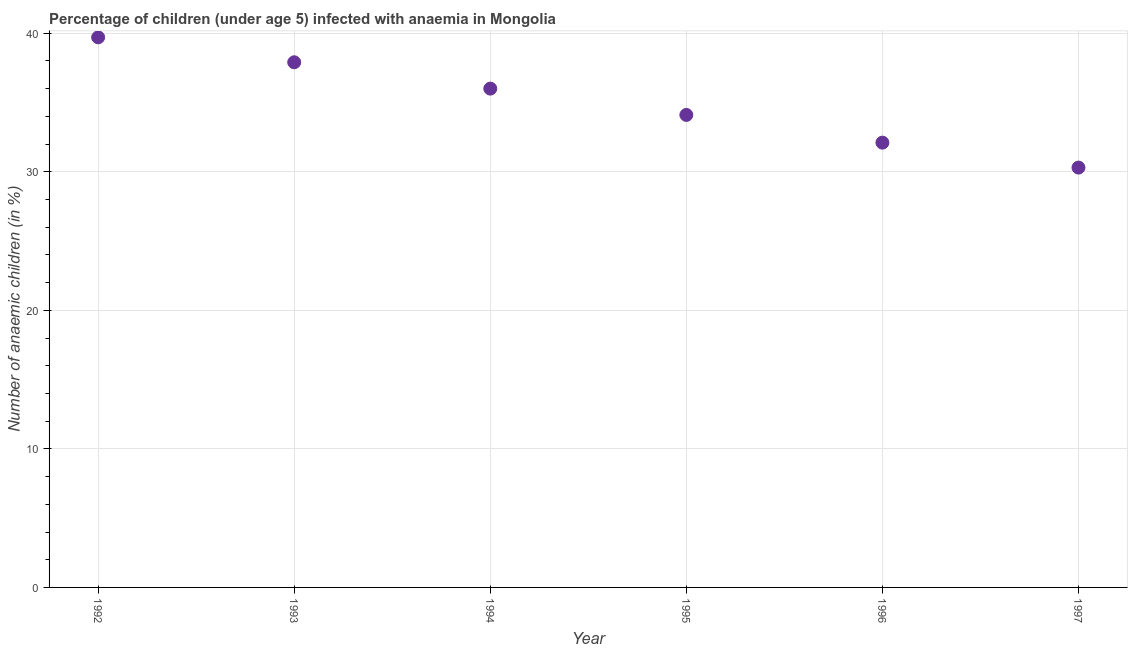What is the number of anaemic children in 1995?
Make the answer very short. 34.1. Across all years, what is the maximum number of anaemic children?
Provide a short and direct response. 39.7. Across all years, what is the minimum number of anaemic children?
Keep it short and to the point. 30.3. In which year was the number of anaemic children minimum?
Make the answer very short. 1997. What is the sum of the number of anaemic children?
Offer a very short reply. 210.1. What is the difference between the number of anaemic children in 1994 and 1997?
Provide a short and direct response. 5.7. What is the average number of anaemic children per year?
Your answer should be compact. 35.02. What is the median number of anaemic children?
Ensure brevity in your answer.  35.05. Do a majority of the years between 1997 and 1993 (inclusive) have number of anaemic children greater than 2 %?
Offer a very short reply. Yes. What is the ratio of the number of anaemic children in 1993 to that in 1995?
Make the answer very short. 1.11. What is the difference between the highest and the second highest number of anaemic children?
Provide a succinct answer. 1.8. What is the difference between the highest and the lowest number of anaemic children?
Give a very brief answer. 9.4. In how many years, is the number of anaemic children greater than the average number of anaemic children taken over all years?
Provide a succinct answer. 3. Does the number of anaemic children monotonically increase over the years?
Your answer should be very brief. No. How many dotlines are there?
Give a very brief answer. 1. How many years are there in the graph?
Offer a terse response. 6. What is the difference between two consecutive major ticks on the Y-axis?
Offer a terse response. 10. Does the graph contain any zero values?
Keep it short and to the point. No. Does the graph contain grids?
Make the answer very short. Yes. What is the title of the graph?
Provide a succinct answer. Percentage of children (under age 5) infected with anaemia in Mongolia. What is the label or title of the Y-axis?
Make the answer very short. Number of anaemic children (in %). What is the Number of anaemic children (in %) in 1992?
Make the answer very short. 39.7. What is the Number of anaemic children (in %) in 1993?
Your answer should be very brief. 37.9. What is the Number of anaemic children (in %) in 1995?
Your answer should be very brief. 34.1. What is the Number of anaemic children (in %) in 1996?
Give a very brief answer. 32.1. What is the Number of anaemic children (in %) in 1997?
Your response must be concise. 30.3. What is the difference between the Number of anaemic children (in %) in 1992 and 1995?
Your answer should be compact. 5.6. What is the difference between the Number of anaemic children (in %) in 1992 and 1996?
Your response must be concise. 7.6. What is the difference between the Number of anaemic children (in %) in 1992 and 1997?
Make the answer very short. 9.4. What is the difference between the Number of anaemic children (in %) in 1993 and 1995?
Your answer should be very brief. 3.8. What is the difference between the Number of anaemic children (in %) in 1993 and 1996?
Give a very brief answer. 5.8. What is the difference between the Number of anaemic children (in %) in 1994 and 1997?
Offer a very short reply. 5.7. What is the difference between the Number of anaemic children (in %) in 1995 and 1997?
Offer a very short reply. 3.8. What is the ratio of the Number of anaemic children (in %) in 1992 to that in 1993?
Offer a very short reply. 1.05. What is the ratio of the Number of anaemic children (in %) in 1992 to that in 1994?
Keep it short and to the point. 1.1. What is the ratio of the Number of anaemic children (in %) in 1992 to that in 1995?
Provide a succinct answer. 1.16. What is the ratio of the Number of anaemic children (in %) in 1992 to that in 1996?
Give a very brief answer. 1.24. What is the ratio of the Number of anaemic children (in %) in 1992 to that in 1997?
Offer a terse response. 1.31. What is the ratio of the Number of anaemic children (in %) in 1993 to that in 1994?
Your response must be concise. 1.05. What is the ratio of the Number of anaemic children (in %) in 1993 to that in 1995?
Provide a short and direct response. 1.11. What is the ratio of the Number of anaemic children (in %) in 1993 to that in 1996?
Your answer should be compact. 1.18. What is the ratio of the Number of anaemic children (in %) in 1993 to that in 1997?
Your answer should be very brief. 1.25. What is the ratio of the Number of anaemic children (in %) in 1994 to that in 1995?
Offer a terse response. 1.06. What is the ratio of the Number of anaemic children (in %) in 1994 to that in 1996?
Your answer should be compact. 1.12. What is the ratio of the Number of anaemic children (in %) in 1994 to that in 1997?
Ensure brevity in your answer.  1.19. What is the ratio of the Number of anaemic children (in %) in 1995 to that in 1996?
Ensure brevity in your answer.  1.06. What is the ratio of the Number of anaemic children (in %) in 1995 to that in 1997?
Provide a short and direct response. 1.12. What is the ratio of the Number of anaemic children (in %) in 1996 to that in 1997?
Provide a short and direct response. 1.06. 